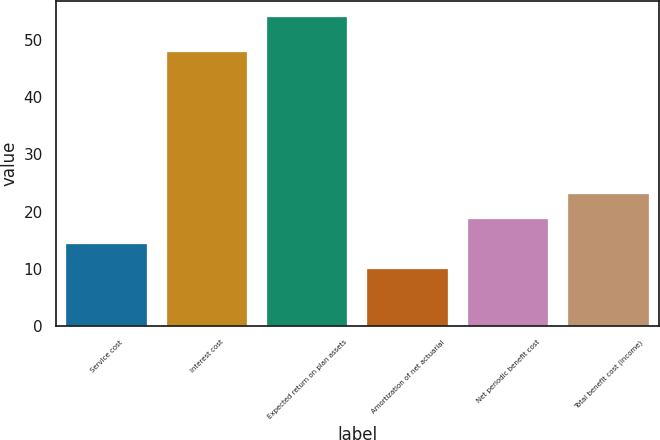Convert chart. <chart><loc_0><loc_0><loc_500><loc_500><bar_chart><fcel>Service cost<fcel>Interest cost<fcel>Expected return on plan assets<fcel>Amortization of net actuarial<fcel>Net periodic benefit cost<fcel>Total benefit cost (income)<nl><fcel>14.32<fcel>48<fcel>54.1<fcel>9.9<fcel>18.74<fcel>23.16<nl></chart> 